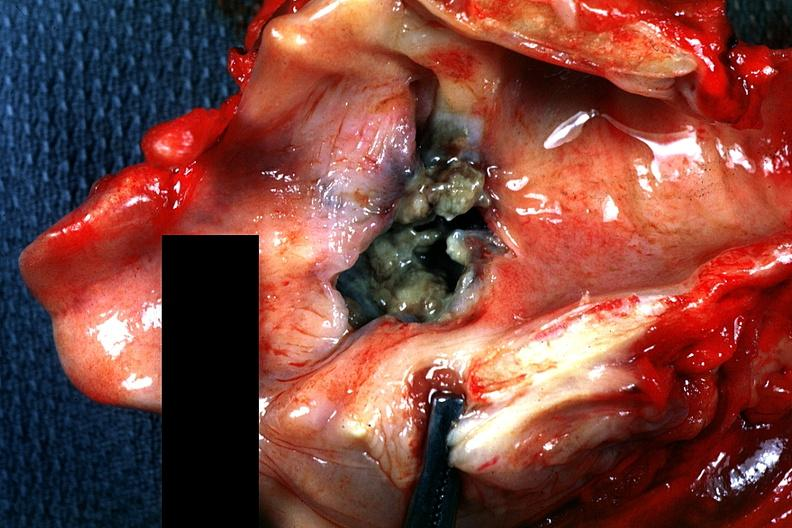what is present?
Answer the question using a single word or phrase. Larynx 